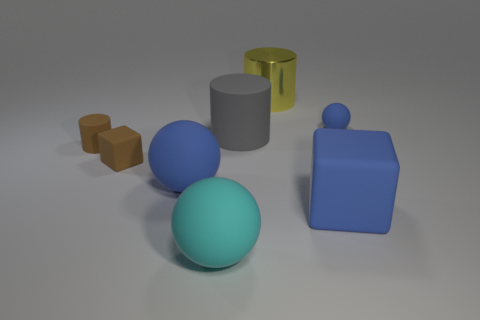Subtract all blue rubber spheres. How many spheres are left? 1 Subtract 1 cylinders. How many cylinders are left? 2 Subtract all spheres. How many objects are left? 5 Add 1 large spheres. How many objects exist? 9 Add 1 big yellow metal things. How many big yellow metal things are left? 2 Add 2 small brown shiny blocks. How many small brown shiny blocks exist? 2 Subtract 0 yellow cubes. How many objects are left? 8 Subtract all big blue rubber objects. Subtract all tiny things. How many objects are left? 3 